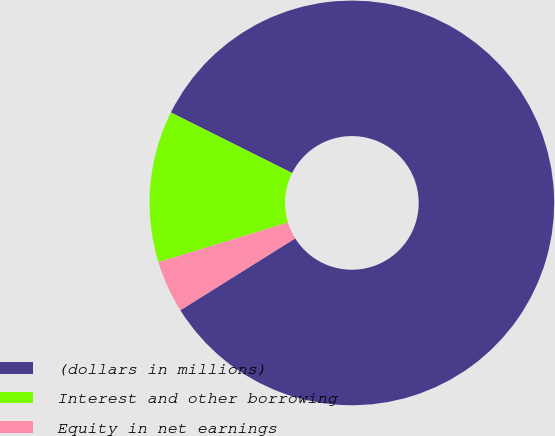Convert chart to OTSL. <chart><loc_0><loc_0><loc_500><loc_500><pie_chart><fcel>(dollars in millions)<fcel>Interest and other borrowing<fcel>Equity in net earnings<nl><fcel>83.73%<fcel>12.11%<fcel>4.16%<nl></chart> 